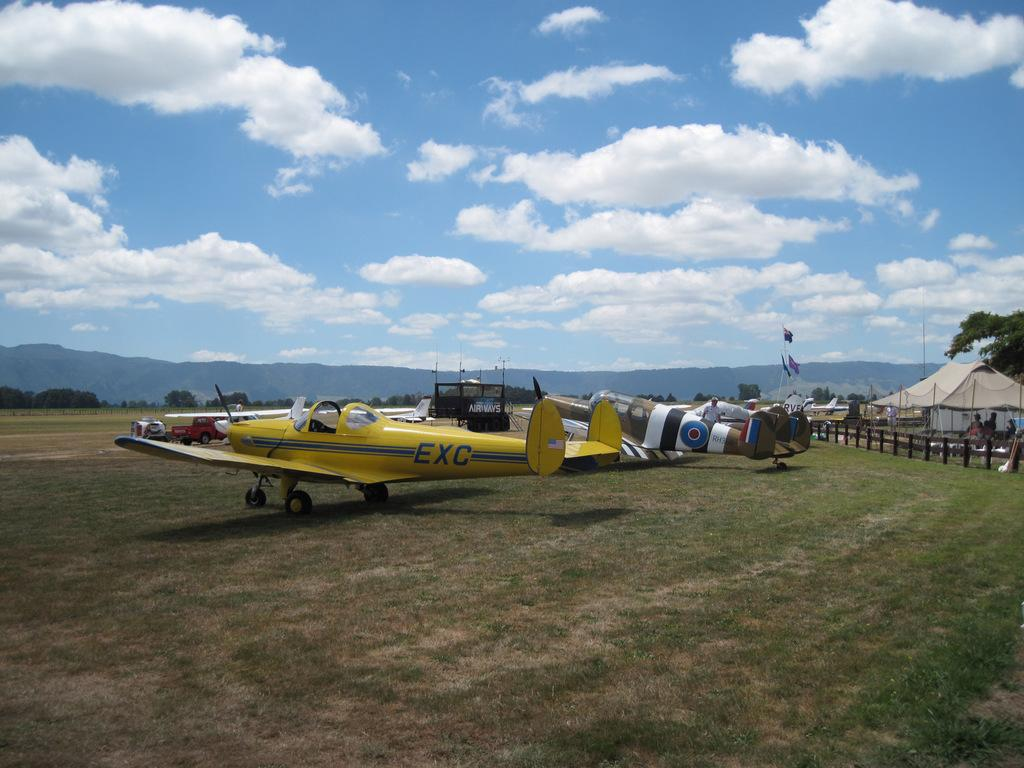What is the main subject of the image? The main subject of the image is airplanes. What else can be seen on the ground in the image? There are vehicles on the grass and tents in the image. Are there any other structures or objects in the image? Yes, there are flags with poles and trees in the image. What is the terrain like in the image? The image shows hills in the background. What is visible in the sky in the image? The sky is visible in the image. Where is the grandmother's nest located in the image? There is no mention of a grandmother or a nest in the image. 